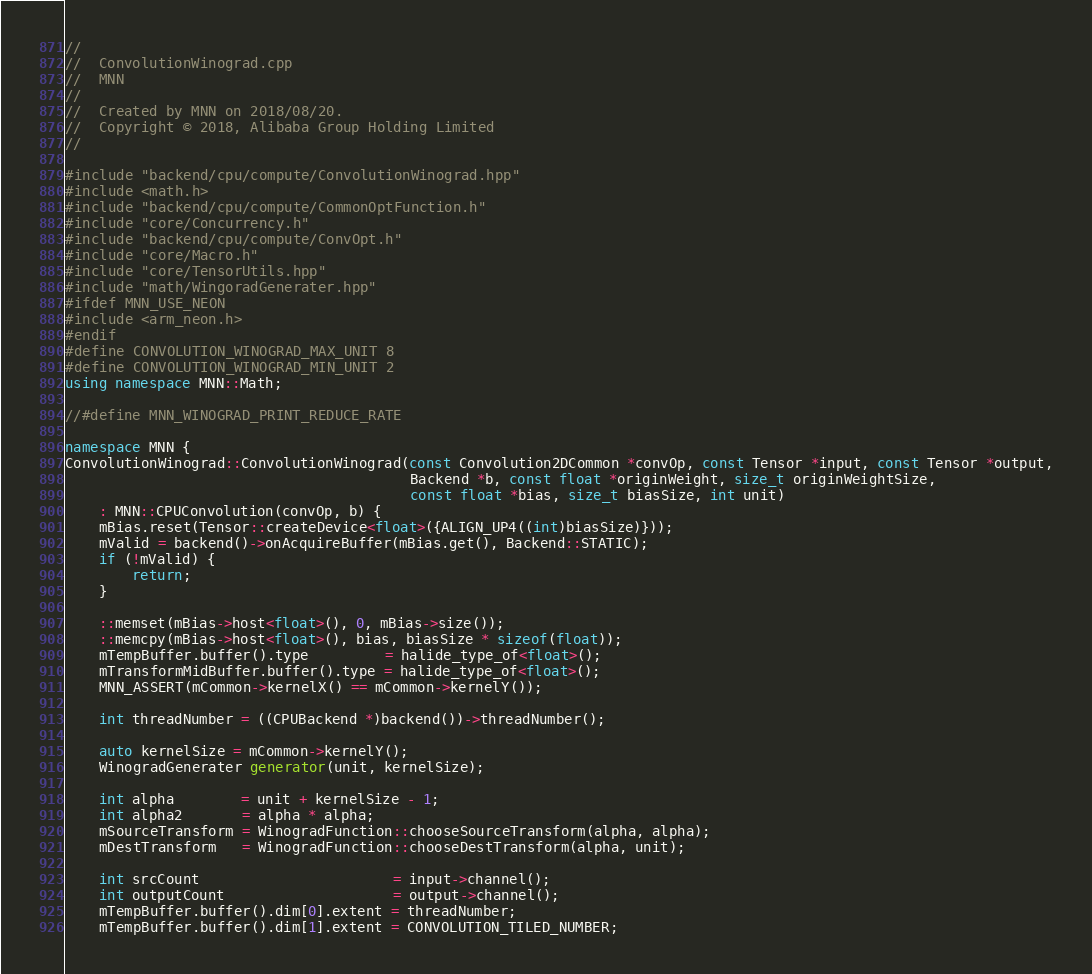Convert code to text. <code><loc_0><loc_0><loc_500><loc_500><_C++_>//
//  ConvolutionWinograd.cpp
//  MNN
//
//  Created by MNN on 2018/08/20.
//  Copyright © 2018, Alibaba Group Holding Limited
//

#include "backend/cpu/compute/ConvolutionWinograd.hpp"
#include <math.h>
#include "backend/cpu/compute/CommonOptFunction.h"
#include "core/Concurrency.h"
#include "backend/cpu/compute/ConvOpt.h"
#include "core/Macro.h"
#include "core/TensorUtils.hpp"
#include "math/WingoradGenerater.hpp"
#ifdef MNN_USE_NEON
#include <arm_neon.h>
#endif
#define CONVOLUTION_WINOGRAD_MAX_UNIT 8
#define CONVOLUTION_WINOGRAD_MIN_UNIT 2
using namespace MNN::Math;

//#define MNN_WINOGRAD_PRINT_REDUCE_RATE

namespace MNN {
ConvolutionWinograd::ConvolutionWinograd(const Convolution2DCommon *convOp, const Tensor *input, const Tensor *output,
                                         Backend *b, const float *originWeight, size_t originWeightSize,
                                         const float *bias, size_t biasSize, int unit)
    : MNN::CPUConvolution(convOp, b) {
    mBias.reset(Tensor::createDevice<float>({ALIGN_UP4((int)biasSize)}));
    mValid = backend()->onAcquireBuffer(mBias.get(), Backend::STATIC);
    if (!mValid) {
        return;
    }

    ::memset(mBias->host<float>(), 0, mBias->size());
    ::memcpy(mBias->host<float>(), bias, biasSize * sizeof(float));
    mTempBuffer.buffer().type         = halide_type_of<float>();
    mTransformMidBuffer.buffer().type = halide_type_of<float>();
    MNN_ASSERT(mCommon->kernelX() == mCommon->kernelY());

    int threadNumber = ((CPUBackend *)backend())->threadNumber();

    auto kernelSize = mCommon->kernelY();
    WinogradGenerater generator(unit, kernelSize);

    int alpha        = unit + kernelSize - 1;
    int alpha2       = alpha * alpha;
    mSourceTransform = WinogradFunction::chooseSourceTransform(alpha, alpha);
    mDestTransform   = WinogradFunction::chooseDestTransform(alpha, unit);

    int srcCount                       = input->channel();
    int outputCount                    = output->channel();
    mTempBuffer.buffer().dim[0].extent = threadNumber;
    mTempBuffer.buffer().dim[1].extent = CONVOLUTION_TILED_NUMBER;</code> 